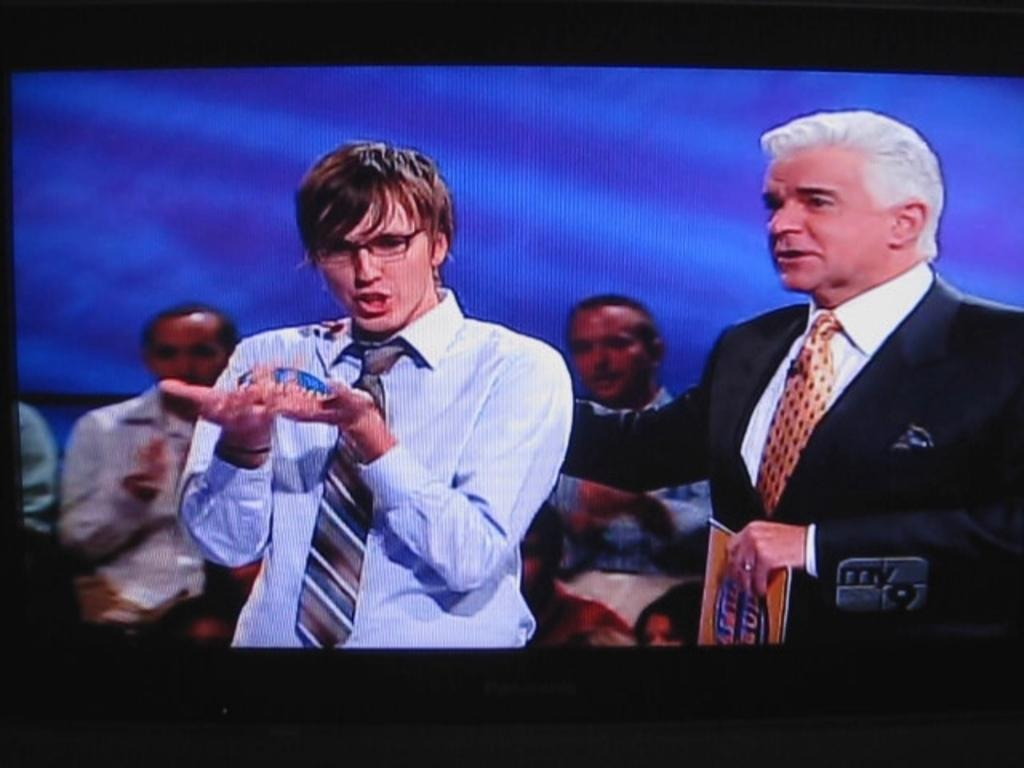<image>
Write a terse but informative summary of the picture. My 9 is airing the game show on the television. 